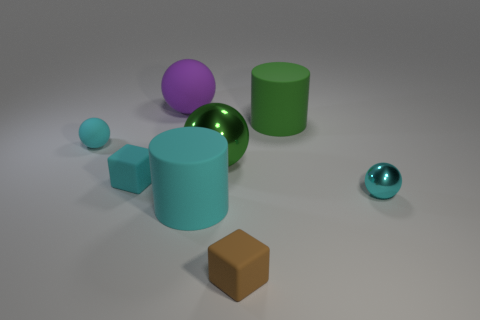Subtract all yellow blocks. How many cyan balls are left? 2 Subtract all green balls. How many balls are left? 3 Add 1 matte spheres. How many objects exist? 9 Subtract all cyan balls. How many balls are left? 2 Subtract all green spheres. Subtract all gray metal objects. How many objects are left? 7 Add 2 small brown things. How many small brown things are left? 3 Add 8 cyan rubber cylinders. How many cyan rubber cylinders exist? 9 Subtract 0 yellow spheres. How many objects are left? 8 Subtract all blocks. How many objects are left? 6 Subtract all cyan cylinders. Subtract all red cubes. How many cylinders are left? 1 